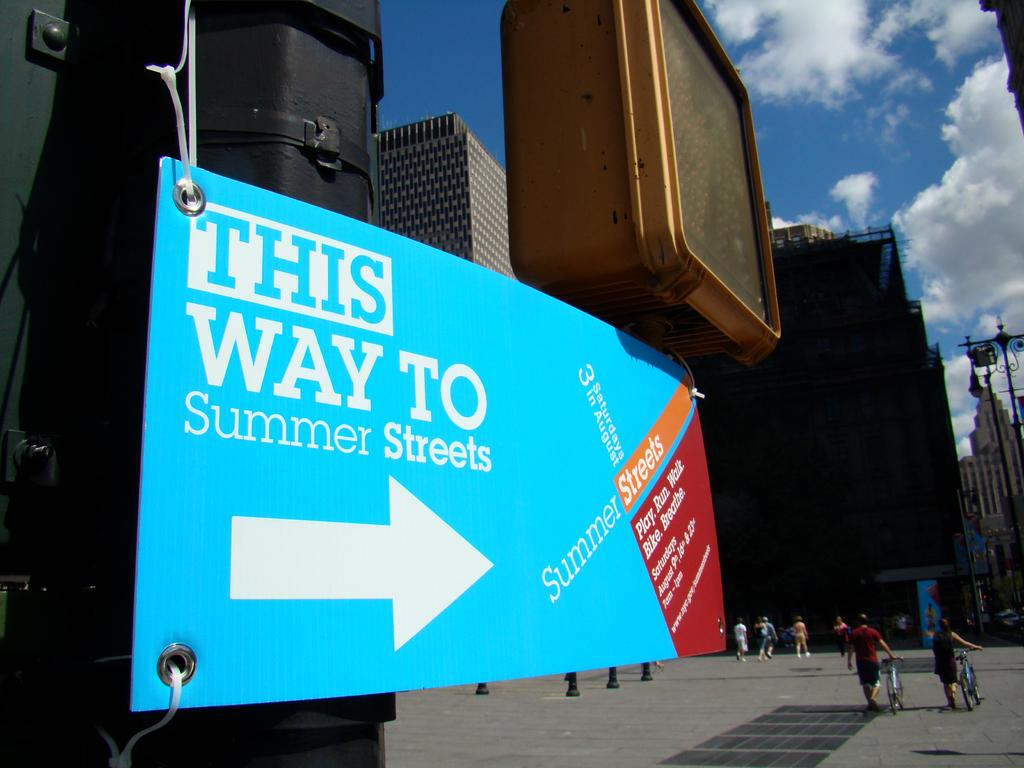<image>
Describe the image concisely. Summer Streets takes place on select Saturdays in August. 